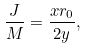Convert formula to latex. <formula><loc_0><loc_0><loc_500><loc_500>\frac { J } { M } = \frac { x r _ { 0 } } { 2 y } ,</formula> 